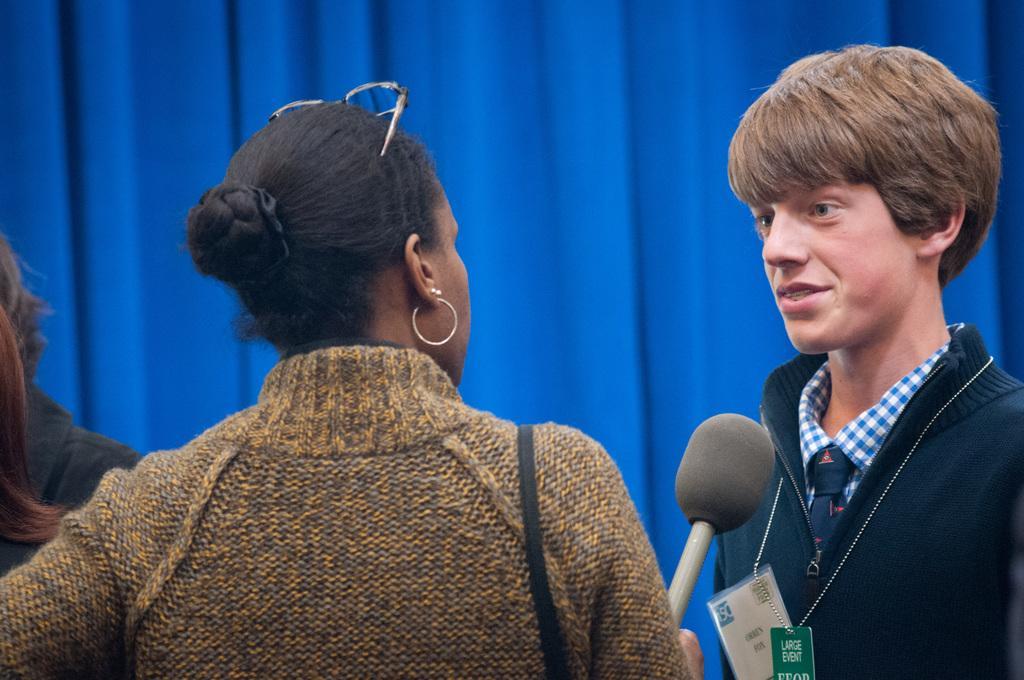Could you give a brief overview of what you see in this image? This image consist of two persons. In the front, the woman wearing brown dress is stand and holding mic. To the right, the boy is wearing black jacket and talking in the mic. In the background, there is a blue cloth. 